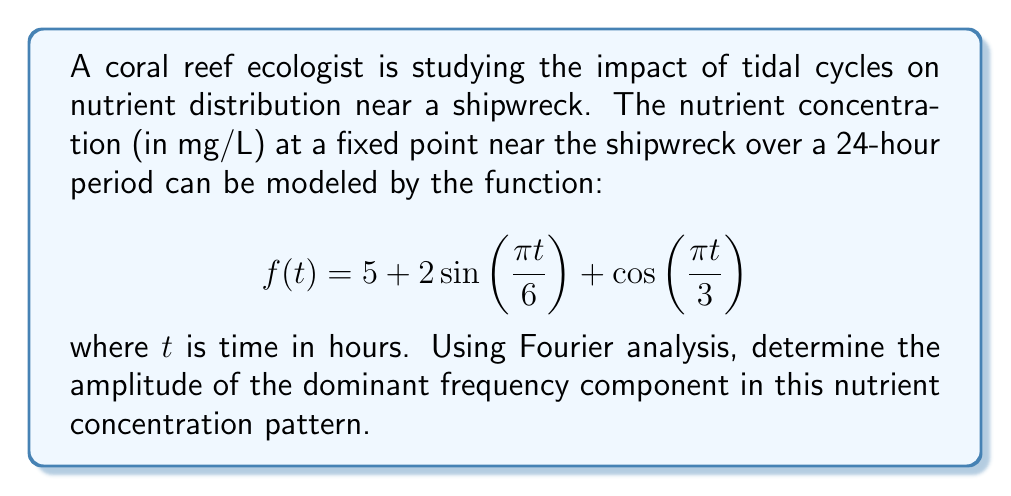Help me with this question. To solve this problem, we need to analyze the given function using Fourier analysis. The function is already expressed as a sum of sinusoidal components, which makes our task easier.

1) First, let's identify the components of the function:
   - Constant term: 5
   - First sinusoidal term: $2\sin\left(\frac{\pi t}{6}\right)$
   - Second sinusoidal term: $\cos\left(\frac{\pi t}{3}\right)$

2) The amplitudes of these components are:
   - For the constant term: 5
   - For $2\sin\left(\frac{\pi t}{6}\right)$: 2
   - For $\cos\left(\frac{\pi t}{3}\right)$: 1

3) The frequencies of the sinusoidal components are:
   - For $2\sin\left(\frac{\pi t}{6}\right)$: $\frac{\pi}{6}$ rad/hour
   - For $\cos\left(\frac{\pi t}{3}\right)$: $\frac{\pi}{3}$ rad/hour

4) To find the dominant frequency component, we compare the amplitudes of the sinusoidal terms. The term with the largest amplitude will be the dominant frequency component.

5) Comparing the amplitudes:
   - $2\sin\left(\frac{\pi t}{6}\right)$ has an amplitude of 2
   - $\cos\left(\frac{\pi t}{3}\right)$ has an amplitude of 1

6) Therefore, the dominant frequency component is $2\sin\left(\frac{\pi t}{6}\right)$, which has an amplitude of 2.
Answer: The amplitude of the dominant frequency component is 2 mg/L. 